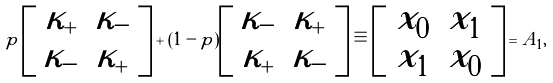<formula> <loc_0><loc_0><loc_500><loc_500>p \left [ \begin{array} { c c } \kappa _ { + } & \kappa _ { - } \\ \kappa _ { - } & \kappa _ { + } \end{array} \right ] + ( 1 - p ) \left [ \begin{array} { c c } \kappa _ { - } & \kappa _ { + } \\ \kappa _ { + } & \kappa _ { - } \end{array} \right ] \equiv \left [ \begin{array} { c c } x _ { 0 } & x _ { 1 } \\ x _ { 1 } & x _ { 0 } \end{array} \right ] = A _ { 1 } ,</formula> 